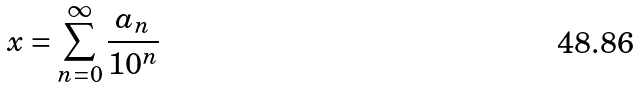<formula> <loc_0><loc_0><loc_500><loc_500>x = \sum _ { n = 0 } ^ { \infty } \frac { a _ { n } } { 1 0 ^ { n } }</formula> 